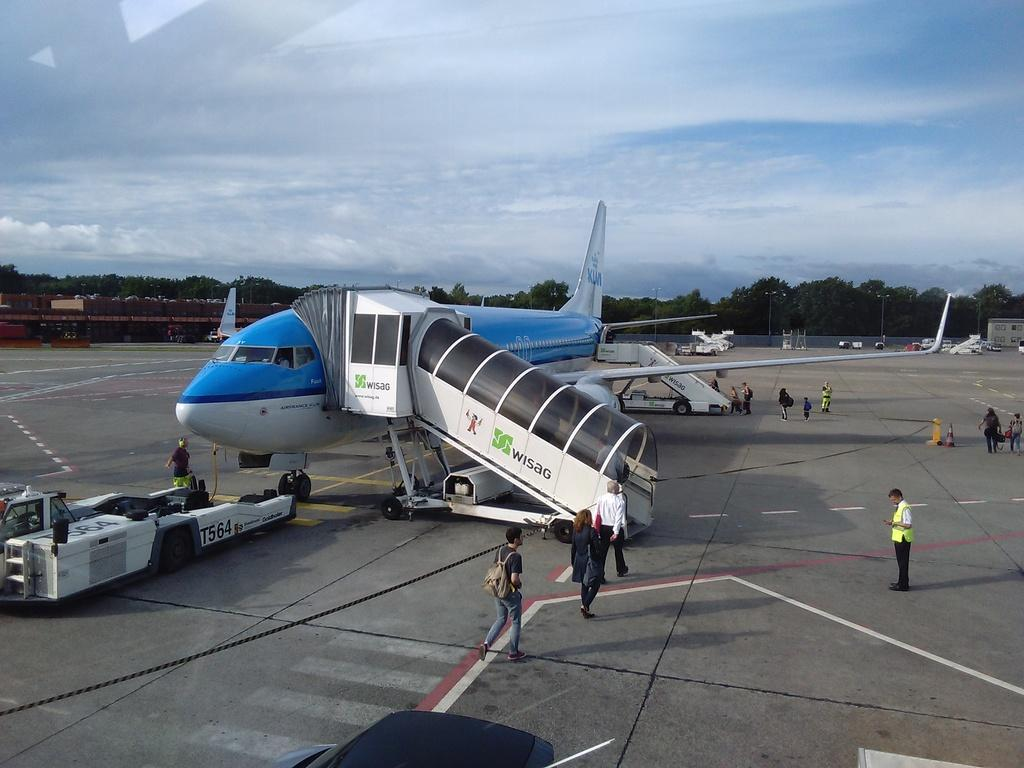<image>
Create a compact narrative representing the image presented. Some people are going into AirFrance aircraft and some officers are helping through the process. 